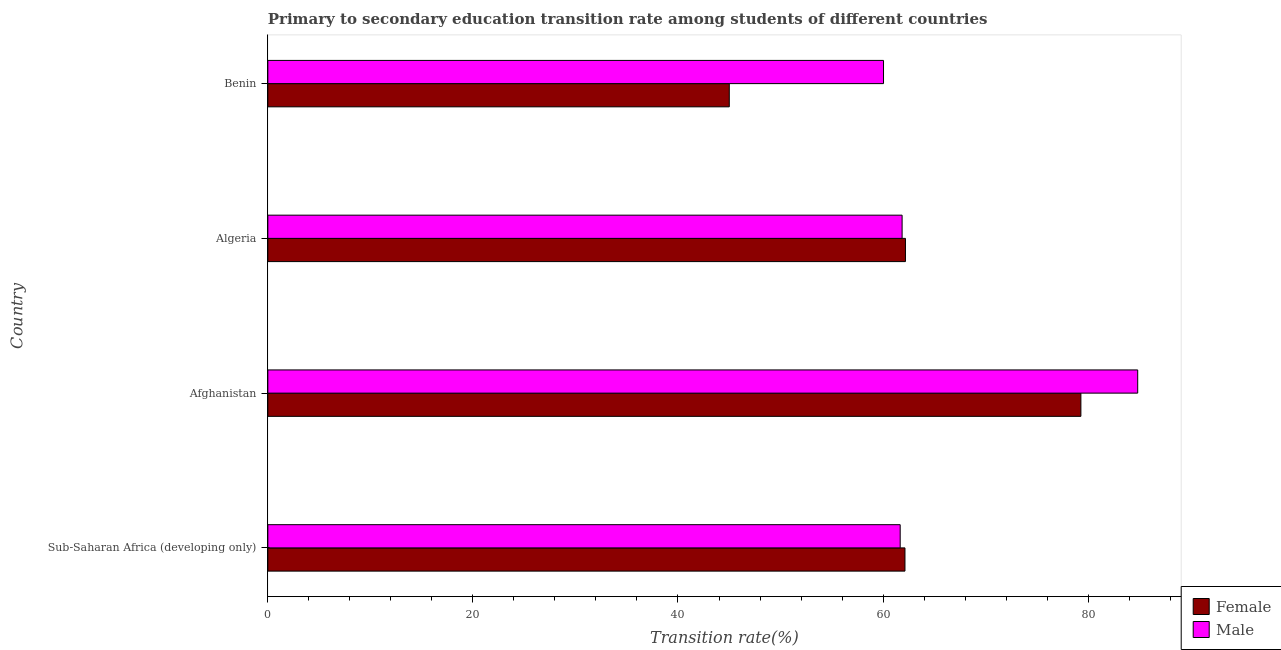How many groups of bars are there?
Ensure brevity in your answer.  4. Are the number of bars per tick equal to the number of legend labels?
Your response must be concise. Yes. Are the number of bars on each tick of the Y-axis equal?
Your answer should be very brief. Yes. How many bars are there on the 3rd tick from the bottom?
Your response must be concise. 2. What is the label of the 1st group of bars from the top?
Provide a succinct answer. Benin. What is the transition rate among female students in Benin?
Your response must be concise. 45. Across all countries, what is the maximum transition rate among female students?
Your response must be concise. 79.29. Across all countries, what is the minimum transition rate among male students?
Offer a very short reply. 60.04. In which country was the transition rate among male students maximum?
Your answer should be very brief. Afghanistan. In which country was the transition rate among male students minimum?
Ensure brevity in your answer.  Benin. What is the total transition rate among female students in the graph?
Your response must be concise. 248.62. What is the difference between the transition rate among male students in Afghanistan and that in Benin?
Your response must be concise. 24.79. What is the difference between the transition rate among male students in Benin and the transition rate among female students in Sub-Saharan Africa (developing only)?
Your answer should be very brief. -2.09. What is the average transition rate among male students per country?
Make the answer very short. 67.1. What is the difference between the transition rate among male students and transition rate among female students in Benin?
Ensure brevity in your answer.  15.04. In how many countries, is the transition rate among male students greater than 68 %?
Offer a terse response. 1. What is the ratio of the transition rate among female students in Afghanistan to that in Algeria?
Your response must be concise. 1.27. What is the difference between the highest and the second highest transition rate among female students?
Your answer should be compact. 17.11. What is the difference between the highest and the lowest transition rate among male students?
Your response must be concise. 24.79. In how many countries, is the transition rate among female students greater than the average transition rate among female students taken over all countries?
Make the answer very short. 2. Is the sum of the transition rate among female students in Afghanistan and Sub-Saharan Africa (developing only) greater than the maximum transition rate among male students across all countries?
Provide a short and direct response. Yes. What does the 1st bar from the top in Sub-Saharan Africa (developing only) represents?
Give a very brief answer. Male. What does the 1st bar from the bottom in Afghanistan represents?
Your response must be concise. Female. How many bars are there?
Keep it short and to the point. 8. Are all the bars in the graph horizontal?
Your answer should be very brief. Yes. What is the difference between two consecutive major ticks on the X-axis?
Your answer should be very brief. 20. Where does the legend appear in the graph?
Keep it short and to the point. Bottom right. How many legend labels are there?
Ensure brevity in your answer.  2. What is the title of the graph?
Make the answer very short. Primary to secondary education transition rate among students of different countries. What is the label or title of the X-axis?
Give a very brief answer. Transition rate(%). What is the Transition rate(%) in Female in Sub-Saharan Africa (developing only)?
Provide a short and direct response. 62.14. What is the Transition rate(%) in Male in Sub-Saharan Africa (developing only)?
Your answer should be compact. 61.67. What is the Transition rate(%) of Female in Afghanistan?
Keep it short and to the point. 79.29. What is the Transition rate(%) of Male in Afghanistan?
Keep it short and to the point. 84.83. What is the Transition rate(%) of Female in Algeria?
Your answer should be very brief. 62.18. What is the Transition rate(%) in Male in Algeria?
Offer a terse response. 61.86. What is the Transition rate(%) of Female in Benin?
Offer a terse response. 45. What is the Transition rate(%) of Male in Benin?
Give a very brief answer. 60.04. Across all countries, what is the maximum Transition rate(%) of Female?
Offer a very short reply. 79.29. Across all countries, what is the maximum Transition rate(%) in Male?
Give a very brief answer. 84.83. Across all countries, what is the minimum Transition rate(%) in Female?
Your answer should be compact. 45. Across all countries, what is the minimum Transition rate(%) of Male?
Give a very brief answer. 60.04. What is the total Transition rate(%) in Female in the graph?
Your answer should be compact. 248.62. What is the total Transition rate(%) of Male in the graph?
Your response must be concise. 268.41. What is the difference between the Transition rate(%) in Female in Sub-Saharan Africa (developing only) and that in Afghanistan?
Your answer should be compact. -17.16. What is the difference between the Transition rate(%) of Male in Sub-Saharan Africa (developing only) and that in Afghanistan?
Your answer should be very brief. -23.16. What is the difference between the Transition rate(%) in Female in Sub-Saharan Africa (developing only) and that in Algeria?
Make the answer very short. -0.05. What is the difference between the Transition rate(%) in Male in Sub-Saharan Africa (developing only) and that in Algeria?
Offer a terse response. -0.19. What is the difference between the Transition rate(%) in Female in Sub-Saharan Africa (developing only) and that in Benin?
Offer a terse response. 17.13. What is the difference between the Transition rate(%) of Male in Sub-Saharan Africa (developing only) and that in Benin?
Offer a terse response. 1.63. What is the difference between the Transition rate(%) in Female in Afghanistan and that in Algeria?
Give a very brief answer. 17.11. What is the difference between the Transition rate(%) of Male in Afghanistan and that in Algeria?
Offer a very short reply. 22.98. What is the difference between the Transition rate(%) in Female in Afghanistan and that in Benin?
Offer a very short reply. 34.29. What is the difference between the Transition rate(%) in Male in Afghanistan and that in Benin?
Your answer should be very brief. 24.79. What is the difference between the Transition rate(%) in Female in Algeria and that in Benin?
Offer a very short reply. 17.18. What is the difference between the Transition rate(%) in Male in Algeria and that in Benin?
Offer a terse response. 1.81. What is the difference between the Transition rate(%) in Female in Sub-Saharan Africa (developing only) and the Transition rate(%) in Male in Afghanistan?
Your answer should be very brief. -22.7. What is the difference between the Transition rate(%) of Female in Sub-Saharan Africa (developing only) and the Transition rate(%) of Male in Algeria?
Your answer should be very brief. 0.28. What is the difference between the Transition rate(%) of Female in Sub-Saharan Africa (developing only) and the Transition rate(%) of Male in Benin?
Provide a succinct answer. 2.09. What is the difference between the Transition rate(%) of Female in Afghanistan and the Transition rate(%) of Male in Algeria?
Offer a very short reply. 17.44. What is the difference between the Transition rate(%) of Female in Afghanistan and the Transition rate(%) of Male in Benin?
Offer a terse response. 19.25. What is the difference between the Transition rate(%) in Female in Algeria and the Transition rate(%) in Male in Benin?
Keep it short and to the point. 2.14. What is the average Transition rate(%) in Female per country?
Your answer should be compact. 62.15. What is the average Transition rate(%) in Male per country?
Give a very brief answer. 67.1. What is the difference between the Transition rate(%) of Female and Transition rate(%) of Male in Sub-Saharan Africa (developing only)?
Your answer should be compact. 0.47. What is the difference between the Transition rate(%) of Female and Transition rate(%) of Male in Afghanistan?
Offer a very short reply. -5.54. What is the difference between the Transition rate(%) in Female and Transition rate(%) in Male in Algeria?
Your answer should be compact. 0.33. What is the difference between the Transition rate(%) of Female and Transition rate(%) of Male in Benin?
Your answer should be very brief. -15.04. What is the ratio of the Transition rate(%) in Female in Sub-Saharan Africa (developing only) to that in Afghanistan?
Your response must be concise. 0.78. What is the ratio of the Transition rate(%) in Male in Sub-Saharan Africa (developing only) to that in Afghanistan?
Provide a succinct answer. 0.73. What is the ratio of the Transition rate(%) of Female in Sub-Saharan Africa (developing only) to that in Algeria?
Your answer should be very brief. 1. What is the ratio of the Transition rate(%) of Male in Sub-Saharan Africa (developing only) to that in Algeria?
Offer a terse response. 1. What is the ratio of the Transition rate(%) of Female in Sub-Saharan Africa (developing only) to that in Benin?
Keep it short and to the point. 1.38. What is the ratio of the Transition rate(%) in Male in Sub-Saharan Africa (developing only) to that in Benin?
Ensure brevity in your answer.  1.03. What is the ratio of the Transition rate(%) in Female in Afghanistan to that in Algeria?
Your response must be concise. 1.28. What is the ratio of the Transition rate(%) of Male in Afghanistan to that in Algeria?
Provide a short and direct response. 1.37. What is the ratio of the Transition rate(%) of Female in Afghanistan to that in Benin?
Provide a succinct answer. 1.76. What is the ratio of the Transition rate(%) in Male in Afghanistan to that in Benin?
Offer a very short reply. 1.41. What is the ratio of the Transition rate(%) in Female in Algeria to that in Benin?
Your response must be concise. 1.38. What is the ratio of the Transition rate(%) of Male in Algeria to that in Benin?
Your answer should be very brief. 1.03. What is the difference between the highest and the second highest Transition rate(%) in Female?
Give a very brief answer. 17.11. What is the difference between the highest and the second highest Transition rate(%) in Male?
Your response must be concise. 22.98. What is the difference between the highest and the lowest Transition rate(%) of Female?
Your response must be concise. 34.29. What is the difference between the highest and the lowest Transition rate(%) of Male?
Give a very brief answer. 24.79. 